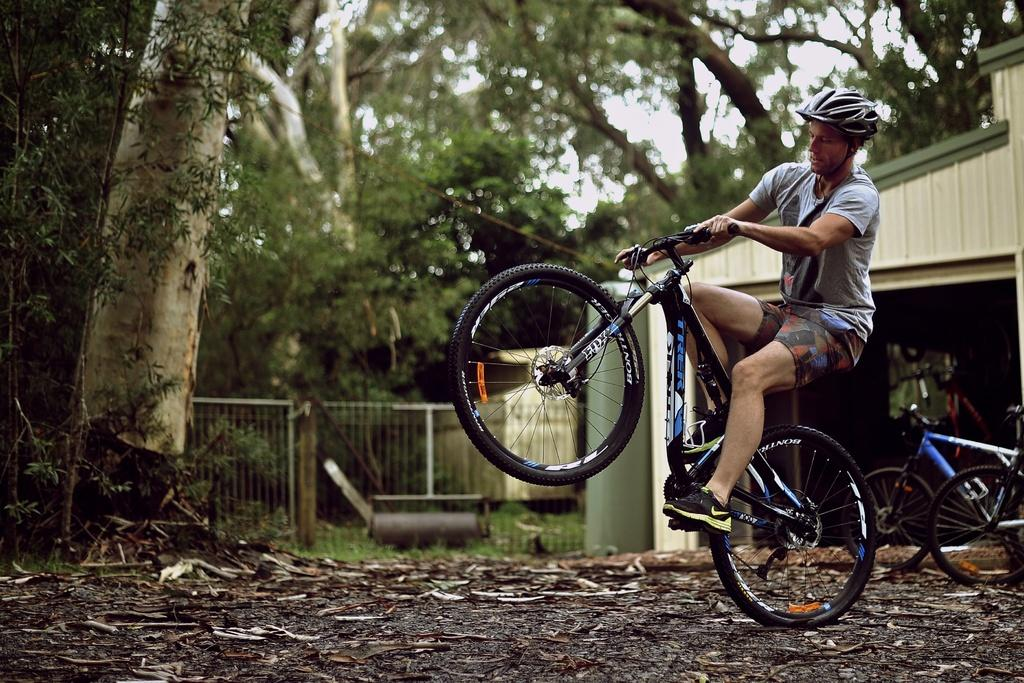What is the man in the image doing? The man is riding a bicycle in the image. What safety precaution is the man taking while riding the bicycle? The man is wearing a helmet. What can be seen in the background of the image? There are trees and the sky visible in the background of the image. What type of soda is the man drinking while riding the bicycle in the image? There is no soda present in the image; the man is riding a bicycle and wearing a helmet. How does the man's self-esteem affect his ability to ride the bicycle in the image? The image does not provide any information about the man's self-esteem, so it cannot be determined how it might affect his ability to ride the bicycle. 